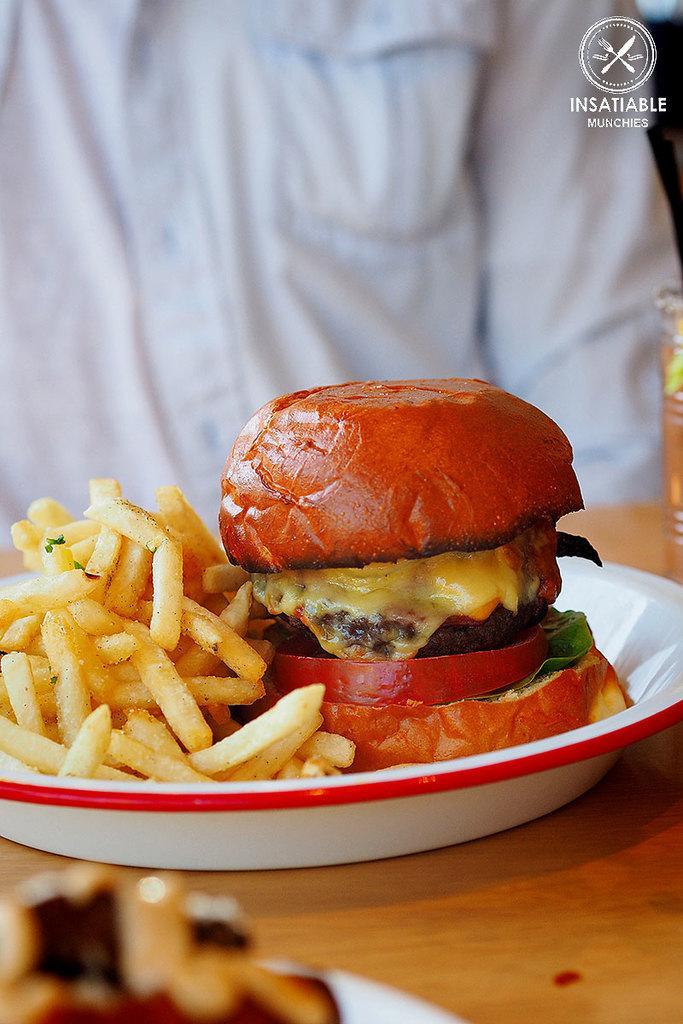Describe this image in one or two sentences. In this image we can see a person. There is some text and logo at the top of the image. There are two food plate are placed on the table. There is an object placed on the table in the image. 